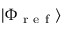<formula> <loc_0><loc_0><loc_500><loc_500>| \Phi _ { r e f } \rangle</formula> 